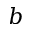<formula> <loc_0><loc_0><loc_500><loc_500>b</formula> 